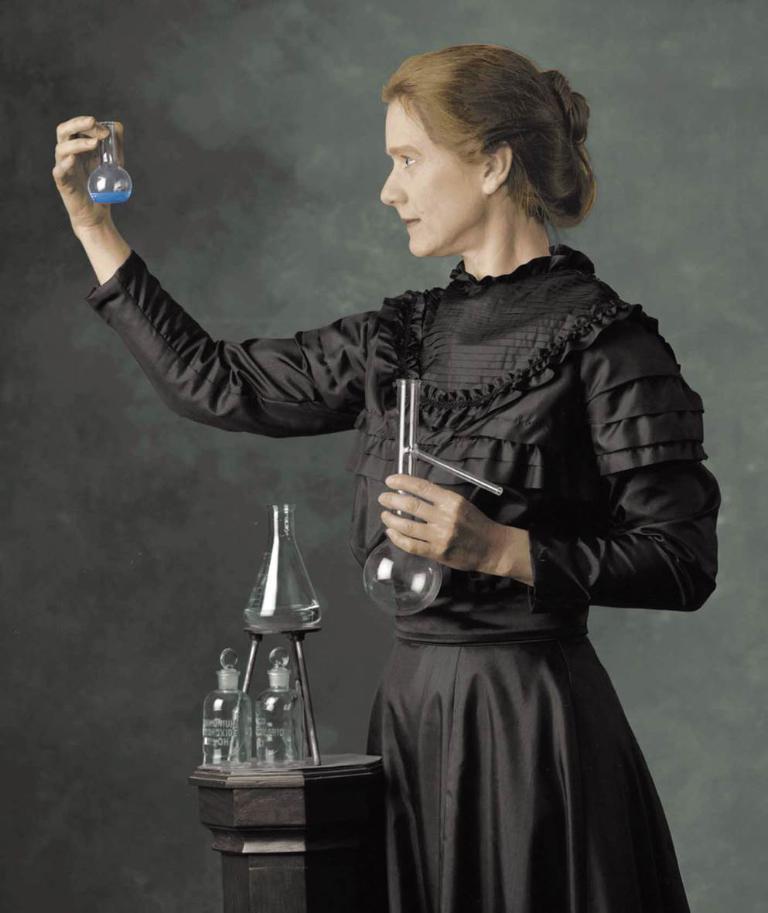In one or two sentences, can you explain what this image depicts? A lady wearing a black dress is holding a glass bottle. In her other hand there is a glass tube. In front of her there is a stand. On the stand there is a stand, glasses and a conical flask. 